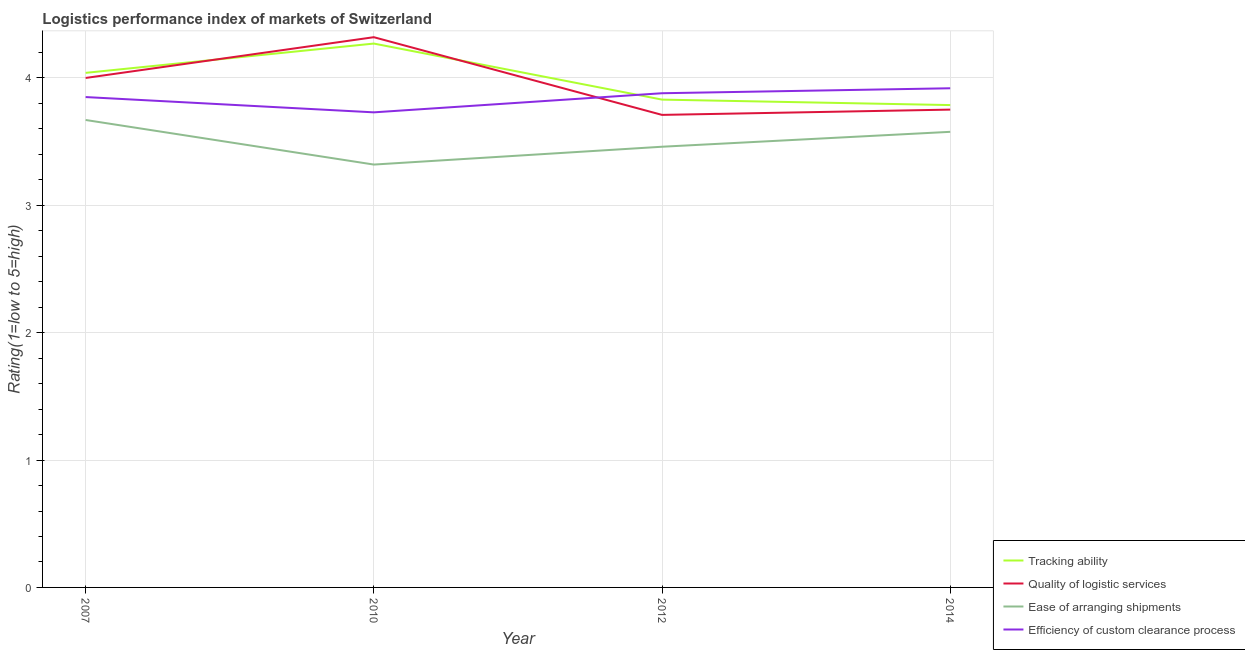How many different coloured lines are there?
Your answer should be compact. 4. What is the lpi rating of ease of arranging shipments in 2012?
Ensure brevity in your answer.  3.46. Across all years, what is the maximum lpi rating of quality of logistic services?
Make the answer very short. 4.32. Across all years, what is the minimum lpi rating of quality of logistic services?
Keep it short and to the point. 3.71. In which year was the lpi rating of quality of logistic services maximum?
Your response must be concise. 2010. In which year was the lpi rating of quality of logistic services minimum?
Provide a short and direct response. 2012. What is the total lpi rating of quality of logistic services in the graph?
Your response must be concise. 15.78. What is the difference between the lpi rating of quality of logistic services in 2010 and that in 2014?
Keep it short and to the point. 0.57. What is the difference between the lpi rating of tracking ability in 2014 and the lpi rating of quality of logistic services in 2007?
Ensure brevity in your answer.  -0.21. What is the average lpi rating of tracking ability per year?
Give a very brief answer. 3.98. In the year 2007, what is the difference between the lpi rating of ease of arranging shipments and lpi rating of tracking ability?
Your answer should be compact. -0.37. In how many years, is the lpi rating of tracking ability greater than 3.2?
Give a very brief answer. 4. What is the ratio of the lpi rating of tracking ability in 2007 to that in 2014?
Your response must be concise. 1.07. Is the lpi rating of efficiency of custom clearance process in 2007 less than that in 2012?
Offer a terse response. Yes. Is the difference between the lpi rating of tracking ability in 2007 and 2012 greater than the difference between the lpi rating of ease of arranging shipments in 2007 and 2012?
Your answer should be very brief. No. What is the difference between the highest and the second highest lpi rating of tracking ability?
Provide a succinct answer. 0.23. What is the difference between the highest and the lowest lpi rating of quality of logistic services?
Ensure brevity in your answer.  0.61. In how many years, is the lpi rating of efficiency of custom clearance process greater than the average lpi rating of efficiency of custom clearance process taken over all years?
Offer a terse response. 3. Is the sum of the lpi rating of efficiency of custom clearance process in 2012 and 2014 greater than the maximum lpi rating of quality of logistic services across all years?
Keep it short and to the point. Yes. Is it the case that in every year, the sum of the lpi rating of tracking ability and lpi rating of quality of logistic services is greater than the lpi rating of ease of arranging shipments?
Your answer should be compact. Yes. Is the lpi rating of quality of logistic services strictly greater than the lpi rating of ease of arranging shipments over the years?
Provide a succinct answer. Yes. Is the lpi rating of quality of logistic services strictly less than the lpi rating of efficiency of custom clearance process over the years?
Offer a terse response. No. How many lines are there?
Your response must be concise. 4. How many years are there in the graph?
Keep it short and to the point. 4. Where does the legend appear in the graph?
Provide a succinct answer. Bottom right. How many legend labels are there?
Ensure brevity in your answer.  4. What is the title of the graph?
Keep it short and to the point. Logistics performance index of markets of Switzerland. Does "Quality Certification" appear as one of the legend labels in the graph?
Offer a terse response. No. What is the label or title of the Y-axis?
Make the answer very short. Rating(1=low to 5=high). What is the Rating(1=low to 5=high) in Tracking ability in 2007?
Make the answer very short. 4.04. What is the Rating(1=low to 5=high) of Ease of arranging shipments in 2007?
Offer a very short reply. 3.67. What is the Rating(1=low to 5=high) of Efficiency of custom clearance process in 2007?
Give a very brief answer. 3.85. What is the Rating(1=low to 5=high) of Tracking ability in 2010?
Provide a succinct answer. 4.27. What is the Rating(1=low to 5=high) in Quality of logistic services in 2010?
Offer a very short reply. 4.32. What is the Rating(1=low to 5=high) of Ease of arranging shipments in 2010?
Offer a very short reply. 3.32. What is the Rating(1=low to 5=high) of Efficiency of custom clearance process in 2010?
Keep it short and to the point. 3.73. What is the Rating(1=low to 5=high) of Tracking ability in 2012?
Ensure brevity in your answer.  3.83. What is the Rating(1=low to 5=high) of Quality of logistic services in 2012?
Offer a terse response. 3.71. What is the Rating(1=low to 5=high) in Ease of arranging shipments in 2012?
Provide a short and direct response. 3.46. What is the Rating(1=low to 5=high) in Efficiency of custom clearance process in 2012?
Offer a very short reply. 3.88. What is the Rating(1=low to 5=high) in Tracking ability in 2014?
Keep it short and to the point. 3.79. What is the Rating(1=low to 5=high) of Quality of logistic services in 2014?
Your answer should be very brief. 3.75. What is the Rating(1=low to 5=high) of Ease of arranging shipments in 2014?
Provide a succinct answer. 3.58. What is the Rating(1=low to 5=high) of Efficiency of custom clearance process in 2014?
Provide a short and direct response. 3.92. Across all years, what is the maximum Rating(1=low to 5=high) of Tracking ability?
Your response must be concise. 4.27. Across all years, what is the maximum Rating(1=low to 5=high) in Quality of logistic services?
Provide a succinct answer. 4.32. Across all years, what is the maximum Rating(1=low to 5=high) in Ease of arranging shipments?
Your answer should be compact. 3.67. Across all years, what is the maximum Rating(1=low to 5=high) in Efficiency of custom clearance process?
Provide a short and direct response. 3.92. Across all years, what is the minimum Rating(1=low to 5=high) in Tracking ability?
Provide a short and direct response. 3.79. Across all years, what is the minimum Rating(1=low to 5=high) in Quality of logistic services?
Make the answer very short. 3.71. Across all years, what is the minimum Rating(1=low to 5=high) of Ease of arranging shipments?
Provide a succinct answer. 3.32. Across all years, what is the minimum Rating(1=low to 5=high) of Efficiency of custom clearance process?
Provide a short and direct response. 3.73. What is the total Rating(1=low to 5=high) of Tracking ability in the graph?
Offer a terse response. 15.93. What is the total Rating(1=low to 5=high) of Quality of logistic services in the graph?
Provide a succinct answer. 15.78. What is the total Rating(1=low to 5=high) in Ease of arranging shipments in the graph?
Your answer should be very brief. 14.03. What is the total Rating(1=low to 5=high) of Efficiency of custom clearance process in the graph?
Your answer should be compact. 15.38. What is the difference between the Rating(1=low to 5=high) of Tracking ability in 2007 and that in 2010?
Provide a succinct answer. -0.23. What is the difference between the Rating(1=low to 5=high) of Quality of logistic services in 2007 and that in 2010?
Keep it short and to the point. -0.32. What is the difference between the Rating(1=low to 5=high) of Efficiency of custom clearance process in 2007 and that in 2010?
Provide a short and direct response. 0.12. What is the difference between the Rating(1=low to 5=high) of Tracking ability in 2007 and that in 2012?
Make the answer very short. 0.21. What is the difference between the Rating(1=low to 5=high) in Quality of logistic services in 2007 and that in 2012?
Give a very brief answer. 0.29. What is the difference between the Rating(1=low to 5=high) in Ease of arranging shipments in 2007 and that in 2012?
Keep it short and to the point. 0.21. What is the difference between the Rating(1=low to 5=high) in Efficiency of custom clearance process in 2007 and that in 2012?
Your answer should be very brief. -0.03. What is the difference between the Rating(1=low to 5=high) in Tracking ability in 2007 and that in 2014?
Give a very brief answer. 0.25. What is the difference between the Rating(1=low to 5=high) in Quality of logistic services in 2007 and that in 2014?
Make the answer very short. 0.25. What is the difference between the Rating(1=low to 5=high) of Ease of arranging shipments in 2007 and that in 2014?
Make the answer very short. 0.09. What is the difference between the Rating(1=low to 5=high) of Efficiency of custom clearance process in 2007 and that in 2014?
Provide a short and direct response. -0.07. What is the difference between the Rating(1=low to 5=high) of Tracking ability in 2010 and that in 2012?
Offer a very short reply. 0.44. What is the difference between the Rating(1=low to 5=high) of Quality of logistic services in 2010 and that in 2012?
Keep it short and to the point. 0.61. What is the difference between the Rating(1=low to 5=high) in Ease of arranging shipments in 2010 and that in 2012?
Your answer should be compact. -0.14. What is the difference between the Rating(1=low to 5=high) in Efficiency of custom clearance process in 2010 and that in 2012?
Offer a very short reply. -0.15. What is the difference between the Rating(1=low to 5=high) of Tracking ability in 2010 and that in 2014?
Give a very brief answer. 0.48. What is the difference between the Rating(1=low to 5=high) of Quality of logistic services in 2010 and that in 2014?
Your answer should be compact. 0.57. What is the difference between the Rating(1=low to 5=high) in Ease of arranging shipments in 2010 and that in 2014?
Give a very brief answer. -0.26. What is the difference between the Rating(1=low to 5=high) of Efficiency of custom clearance process in 2010 and that in 2014?
Your answer should be very brief. -0.19. What is the difference between the Rating(1=low to 5=high) of Tracking ability in 2012 and that in 2014?
Your answer should be very brief. 0.04. What is the difference between the Rating(1=low to 5=high) in Quality of logistic services in 2012 and that in 2014?
Provide a succinct answer. -0.04. What is the difference between the Rating(1=low to 5=high) in Ease of arranging shipments in 2012 and that in 2014?
Give a very brief answer. -0.12. What is the difference between the Rating(1=low to 5=high) of Efficiency of custom clearance process in 2012 and that in 2014?
Make the answer very short. -0.04. What is the difference between the Rating(1=low to 5=high) of Tracking ability in 2007 and the Rating(1=low to 5=high) of Quality of logistic services in 2010?
Your response must be concise. -0.28. What is the difference between the Rating(1=low to 5=high) in Tracking ability in 2007 and the Rating(1=low to 5=high) in Ease of arranging shipments in 2010?
Make the answer very short. 0.72. What is the difference between the Rating(1=low to 5=high) of Tracking ability in 2007 and the Rating(1=low to 5=high) of Efficiency of custom clearance process in 2010?
Offer a very short reply. 0.31. What is the difference between the Rating(1=low to 5=high) of Quality of logistic services in 2007 and the Rating(1=low to 5=high) of Ease of arranging shipments in 2010?
Give a very brief answer. 0.68. What is the difference between the Rating(1=low to 5=high) of Quality of logistic services in 2007 and the Rating(1=low to 5=high) of Efficiency of custom clearance process in 2010?
Offer a very short reply. 0.27. What is the difference between the Rating(1=low to 5=high) of Ease of arranging shipments in 2007 and the Rating(1=low to 5=high) of Efficiency of custom clearance process in 2010?
Provide a short and direct response. -0.06. What is the difference between the Rating(1=low to 5=high) in Tracking ability in 2007 and the Rating(1=low to 5=high) in Quality of logistic services in 2012?
Your answer should be very brief. 0.33. What is the difference between the Rating(1=low to 5=high) of Tracking ability in 2007 and the Rating(1=low to 5=high) of Ease of arranging shipments in 2012?
Your answer should be compact. 0.58. What is the difference between the Rating(1=low to 5=high) of Tracking ability in 2007 and the Rating(1=low to 5=high) of Efficiency of custom clearance process in 2012?
Make the answer very short. 0.16. What is the difference between the Rating(1=low to 5=high) of Quality of logistic services in 2007 and the Rating(1=low to 5=high) of Ease of arranging shipments in 2012?
Provide a succinct answer. 0.54. What is the difference between the Rating(1=low to 5=high) of Quality of logistic services in 2007 and the Rating(1=low to 5=high) of Efficiency of custom clearance process in 2012?
Make the answer very short. 0.12. What is the difference between the Rating(1=low to 5=high) in Ease of arranging shipments in 2007 and the Rating(1=low to 5=high) in Efficiency of custom clearance process in 2012?
Ensure brevity in your answer.  -0.21. What is the difference between the Rating(1=low to 5=high) in Tracking ability in 2007 and the Rating(1=low to 5=high) in Quality of logistic services in 2014?
Your response must be concise. 0.29. What is the difference between the Rating(1=low to 5=high) in Tracking ability in 2007 and the Rating(1=low to 5=high) in Ease of arranging shipments in 2014?
Provide a succinct answer. 0.46. What is the difference between the Rating(1=low to 5=high) of Tracking ability in 2007 and the Rating(1=low to 5=high) of Efficiency of custom clearance process in 2014?
Your answer should be compact. 0.12. What is the difference between the Rating(1=low to 5=high) of Quality of logistic services in 2007 and the Rating(1=low to 5=high) of Ease of arranging shipments in 2014?
Keep it short and to the point. 0.42. What is the difference between the Rating(1=low to 5=high) in Quality of logistic services in 2007 and the Rating(1=low to 5=high) in Efficiency of custom clearance process in 2014?
Provide a short and direct response. 0.08. What is the difference between the Rating(1=low to 5=high) of Ease of arranging shipments in 2007 and the Rating(1=low to 5=high) of Efficiency of custom clearance process in 2014?
Keep it short and to the point. -0.25. What is the difference between the Rating(1=low to 5=high) in Tracking ability in 2010 and the Rating(1=low to 5=high) in Quality of logistic services in 2012?
Offer a very short reply. 0.56. What is the difference between the Rating(1=low to 5=high) in Tracking ability in 2010 and the Rating(1=low to 5=high) in Ease of arranging shipments in 2012?
Ensure brevity in your answer.  0.81. What is the difference between the Rating(1=low to 5=high) of Tracking ability in 2010 and the Rating(1=low to 5=high) of Efficiency of custom clearance process in 2012?
Keep it short and to the point. 0.39. What is the difference between the Rating(1=low to 5=high) of Quality of logistic services in 2010 and the Rating(1=low to 5=high) of Ease of arranging shipments in 2012?
Make the answer very short. 0.86. What is the difference between the Rating(1=low to 5=high) of Quality of logistic services in 2010 and the Rating(1=low to 5=high) of Efficiency of custom clearance process in 2012?
Offer a terse response. 0.44. What is the difference between the Rating(1=low to 5=high) of Ease of arranging shipments in 2010 and the Rating(1=low to 5=high) of Efficiency of custom clearance process in 2012?
Offer a terse response. -0.56. What is the difference between the Rating(1=low to 5=high) in Tracking ability in 2010 and the Rating(1=low to 5=high) in Quality of logistic services in 2014?
Offer a terse response. 0.52. What is the difference between the Rating(1=low to 5=high) in Tracking ability in 2010 and the Rating(1=low to 5=high) in Ease of arranging shipments in 2014?
Provide a short and direct response. 0.69. What is the difference between the Rating(1=low to 5=high) in Tracking ability in 2010 and the Rating(1=low to 5=high) in Efficiency of custom clearance process in 2014?
Give a very brief answer. 0.35. What is the difference between the Rating(1=low to 5=high) of Quality of logistic services in 2010 and the Rating(1=low to 5=high) of Ease of arranging shipments in 2014?
Offer a very short reply. 0.74. What is the difference between the Rating(1=low to 5=high) in Quality of logistic services in 2010 and the Rating(1=low to 5=high) in Efficiency of custom clearance process in 2014?
Provide a short and direct response. 0.4. What is the difference between the Rating(1=low to 5=high) of Ease of arranging shipments in 2010 and the Rating(1=low to 5=high) of Efficiency of custom clearance process in 2014?
Your answer should be compact. -0.6. What is the difference between the Rating(1=low to 5=high) in Tracking ability in 2012 and the Rating(1=low to 5=high) in Quality of logistic services in 2014?
Offer a terse response. 0.08. What is the difference between the Rating(1=low to 5=high) of Tracking ability in 2012 and the Rating(1=low to 5=high) of Ease of arranging shipments in 2014?
Make the answer very short. 0.25. What is the difference between the Rating(1=low to 5=high) in Tracking ability in 2012 and the Rating(1=low to 5=high) in Efficiency of custom clearance process in 2014?
Your answer should be compact. -0.09. What is the difference between the Rating(1=low to 5=high) of Quality of logistic services in 2012 and the Rating(1=low to 5=high) of Ease of arranging shipments in 2014?
Keep it short and to the point. 0.13. What is the difference between the Rating(1=low to 5=high) of Quality of logistic services in 2012 and the Rating(1=low to 5=high) of Efficiency of custom clearance process in 2014?
Provide a succinct answer. -0.21. What is the difference between the Rating(1=low to 5=high) in Ease of arranging shipments in 2012 and the Rating(1=low to 5=high) in Efficiency of custom clearance process in 2014?
Ensure brevity in your answer.  -0.46. What is the average Rating(1=low to 5=high) in Tracking ability per year?
Provide a short and direct response. 3.98. What is the average Rating(1=low to 5=high) of Quality of logistic services per year?
Provide a succinct answer. 3.95. What is the average Rating(1=low to 5=high) in Ease of arranging shipments per year?
Offer a terse response. 3.51. What is the average Rating(1=low to 5=high) of Efficiency of custom clearance process per year?
Provide a succinct answer. 3.84. In the year 2007, what is the difference between the Rating(1=low to 5=high) of Tracking ability and Rating(1=low to 5=high) of Ease of arranging shipments?
Your answer should be very brief. 0.37. In the year 2007, what is the difference between the Rating(1=low to 5=high) in Tracking ability and Rating(1=low to 5=high) in Efficiency of custom clearance process?
Provide a short and direct response. 0.19. In the year 2007, what is the difference between the Rating(1=low to 5=high) in Quality of logistic services and Rating(1=low to 5=high) in Ease of arranging shipments?
Keep it short and to the point. 0.33. In the year 2007, what is the difference between the Rating(1=low to 5=high) in Quality of logistic services and Rating(1=low to 5=high) in Efficiency of custom clearance process?
Provide a short and direct response. 0.15. In the year 2007, what is the difference between the Rating(1=low to 5=high) in Ease of arranging shipments and Rating(1=low to 5=high) in Efficiency of custom clearance process?
Ensure brevity in your answer.  -0.18. In the year 2010, what is the difference between the Rating(1=low to 5=high) in Tracking ability and Rating(1=low to 5=high) in Ease of arranging shipments?
Ensure brevity in your answer.  0.95. In the year 2010, what is the difference between the Rating(1=low to 5=high) in Tracking ability and Rating(1=low to 5=high) in Efficiency of custom clearance process?
Ensure brevity in your answer.  0.54. In the year 2010, what is the difference between the Rating(1=low to 5=high) in Quality of logistic services and Rating(1=low to 5=high) in Efficiency of custom clearance process?
Provide a short and direct response. 0.59. In the year 2010, what is the difference between the Rating(1=low to 5=high) in Ease of arranging shipments and Rating(1=low to 5=high) in Efficiency of custom clearance process?
Your answer should be compact. -0.41. In the year 2012, what is the difference between the Rating(1=low to 5=high) of Tracking ability and Rating(1=low to 5=high) of Quality of logistic services?
Offer a very short reply. 0.12. In the year 2012, what is the difference between the Rating(1=low to 5=high) of Tracking ability and Rating(1=low to 5=high) of Ease of arranging shipments?
Ensure brevity in your answer.  0.37. In the year 2012, what is the difference between the Rating(1=low to 5=high) in Tracking ability and Rating(1=low to 5=high) in Efficiency of custom clearance process?
Offer a terse response. -0.05. In the year 2012, what is the difference between the Rating(1=low to 5=high) of Quality of logistic services and Rating(1=low to 5=high) of Efficiency of custom clearance process?
Provide a short and direct response. -0.17. In the year 2012, what is the difference between the Rating(1=low to 5=high) in Ease of arranging shipments and Rating(1=low to 5=high) in Efficiency of custom clearance process?
Offer a terse response. -0.42. In the year 2014, what is the difference between the Rating(1=low to 5=high) in Tracking ability and Rating(1=low to 5=high) in Quality of logistic services?
Offer a very short reply. 0.04. In the year 2014, what is the difference between the Rating(1=low to 5=high) of Tracking ability and Rating(1=low to 5=high) of Ease of arranging shipments?
Your answer should be very brief. 0.21. In the year 2014, what is the difference between the Rating(1=low to 5=high) in Tracking ability and Rating(1=low to 5=high) in Efficiency of custom clearance process?
Provide a succinct answer. -0.13. In the year 2014, what is the difference between the Rating(1=low to 5=high) in Quality of logistic services and Rating(1=low to 5=high) in Ease of arranging shipments?
Make the answer very short. 0.17. In the year 2014, what is the difference between the Rating(1=low to 5=high) of Quality of logistic services and Rating(1=low to 5=high) of Efficiency of custom clearance process?
Make the answer very short. -0.17. In the year 2014, what is the difference between the Rating(1=low to 5=high) of Ease of arranging shipments and Rating(1=low to 5=high) of Efficiency of custom clearance process?
Keep it short and to the point. -0.34. What is the ratio of the Rating(1=low to 5=high) of Tracking ability in 2007 to that in 2010?
Offer a terse response. 0.95. What is the ratio of the Rating(1=low to 5=high) of Quality of logistic services in 2007 to that in 2010?
Keep it short and to the point. 0.93. What is the ratio of the Rating(1=low to 5=high) in Ease of arranging shipments in 2007 to that in 2010?
Keep it short and to the point. 1.11. What is the ratio of the Rating(1=low to 5=high) of Efficiency of custom clearance process in 2007 to that in 2010?
Your response must be concise. 1.03. What is the ratio of the Rating(1=low to 5=high) of Tracking ability in 2007 to that in 2012?
Ensure brevity in your answer.  1.05. What is the ratio of the Rating(1=low to 5=high) in Quality of logistic services in 2007 to that in 2012?
Your answer should be very brief. 1.08. What is the ratio of the Rating(1=low to 5=high) in Ease of arranging shipments in 2007 to that in 2012?
Your answer should be compact. 1.06. What is the ratio of the Rating(1=low to 5=high) in Efficiency of custom clearance process in 2007 to that in 2012?
Your answer should be very brief. 0.99. What is the ratio of the Rating(1=low to 5=high) in Tracking ability in 2007 to that in 2014?
Make the answer very short. 1.07. What is the ratio of the Rating(1=low to 5=high) in Quality of logistic services in 2007 to that in 2014?
Provide a short and direct response. 1.07. What is the ratio of the Rating(1=low to 5=high) in Efficiency of custom clearance process in 2007 to that in 2014?
Keep it short and to the point. 0.98. What is the ratio of the Rating(1=low to 5=high) of Tracking ability in 2010 to that in 2012?
Your answer should be compact. 1.11. What is the ratio of the Rating(1=low to 5=high) in Quality of logistic services in 2010 to that in 2012?
Keep it short and to the point. 1.16. What is the ratio of the Rating(1=low to 5=high) of Ease of arranging shipments in 2010 to that in 2012?
Provide a succinct answer. 0.96. What is the ratio of the Rating(1=low to 5=high) of Efficiency of custom clearance process in 2010 to that in 2012?
Ensure brevity in your answer.  0.96. What is the ratio of the Rating(1=low to 5=high) of Tracking ability in 2010 to that in 2014?
Ensure brevity in your answer.  1.13. What is the ratio of the Rating(1=low to 5=high) in Quality of logistic services in 2010 to that in 2014?
Provide a short and direct response. 1.15. What is the ratio of the Rating(1=low to 5=high) of Ease of arranging shipments in 2010 to that in 2014?
Offer a terse response. 0.93. What is the ratio of the Rating(1=low to 5=high) in Efficiency of custom clearance process in 2010 to that in 2014?
Provide a short and direct response. 0.95. What is the ratio of the Rating(1=low to 5=high) of Tracking ability in 2012 to that in 2014?
Your answer should be very brief. 1.01. What is the ratio of the Rating(1=low to 5=high) in Ease of arranging shipments in 2012 to that in 2014?
Give a very brief answer. 0.97. What is the ratio of the Rating(1=low to 5=high) of Efficiency of custom clearance process in 2012 to that in 2014?
Give a very brief answer. 0.99. What is the difference between the highest and the second highest Rating(1=low to 5=high) in Tracking ability?
Offer a terse response. 0.23. What is the difference between the highest and the second highest Rating(1=low to 5=high) of Quality of logistic services?
Provide a succinct answer. 0.32. What is the difference between the highest and the second highest Rating(1=low to 5=high) in Ease of arranging shipments?
Your answer should be very brief. 0.09. What is the difference between the highest and the second highest Rating(1=low to 5=high) in Efficiency of custom clearance process?
Keep it short and to the point. 0.04. What is the difference between the highest and the lowest Rating(1=low to 5=high) in Tracking ability?
Keep it short and to the point. 0.48. What is the difference between the highest and the lowest Rating(1=low to 5=high) of Quality of logistic services?
Your response must be concise. 0.61. What is the difference between the highest and the lowest Rating(1=low to 5=high) of Efficiency of custom clearance process?
Ensure brevity in your answer.  0.19. 